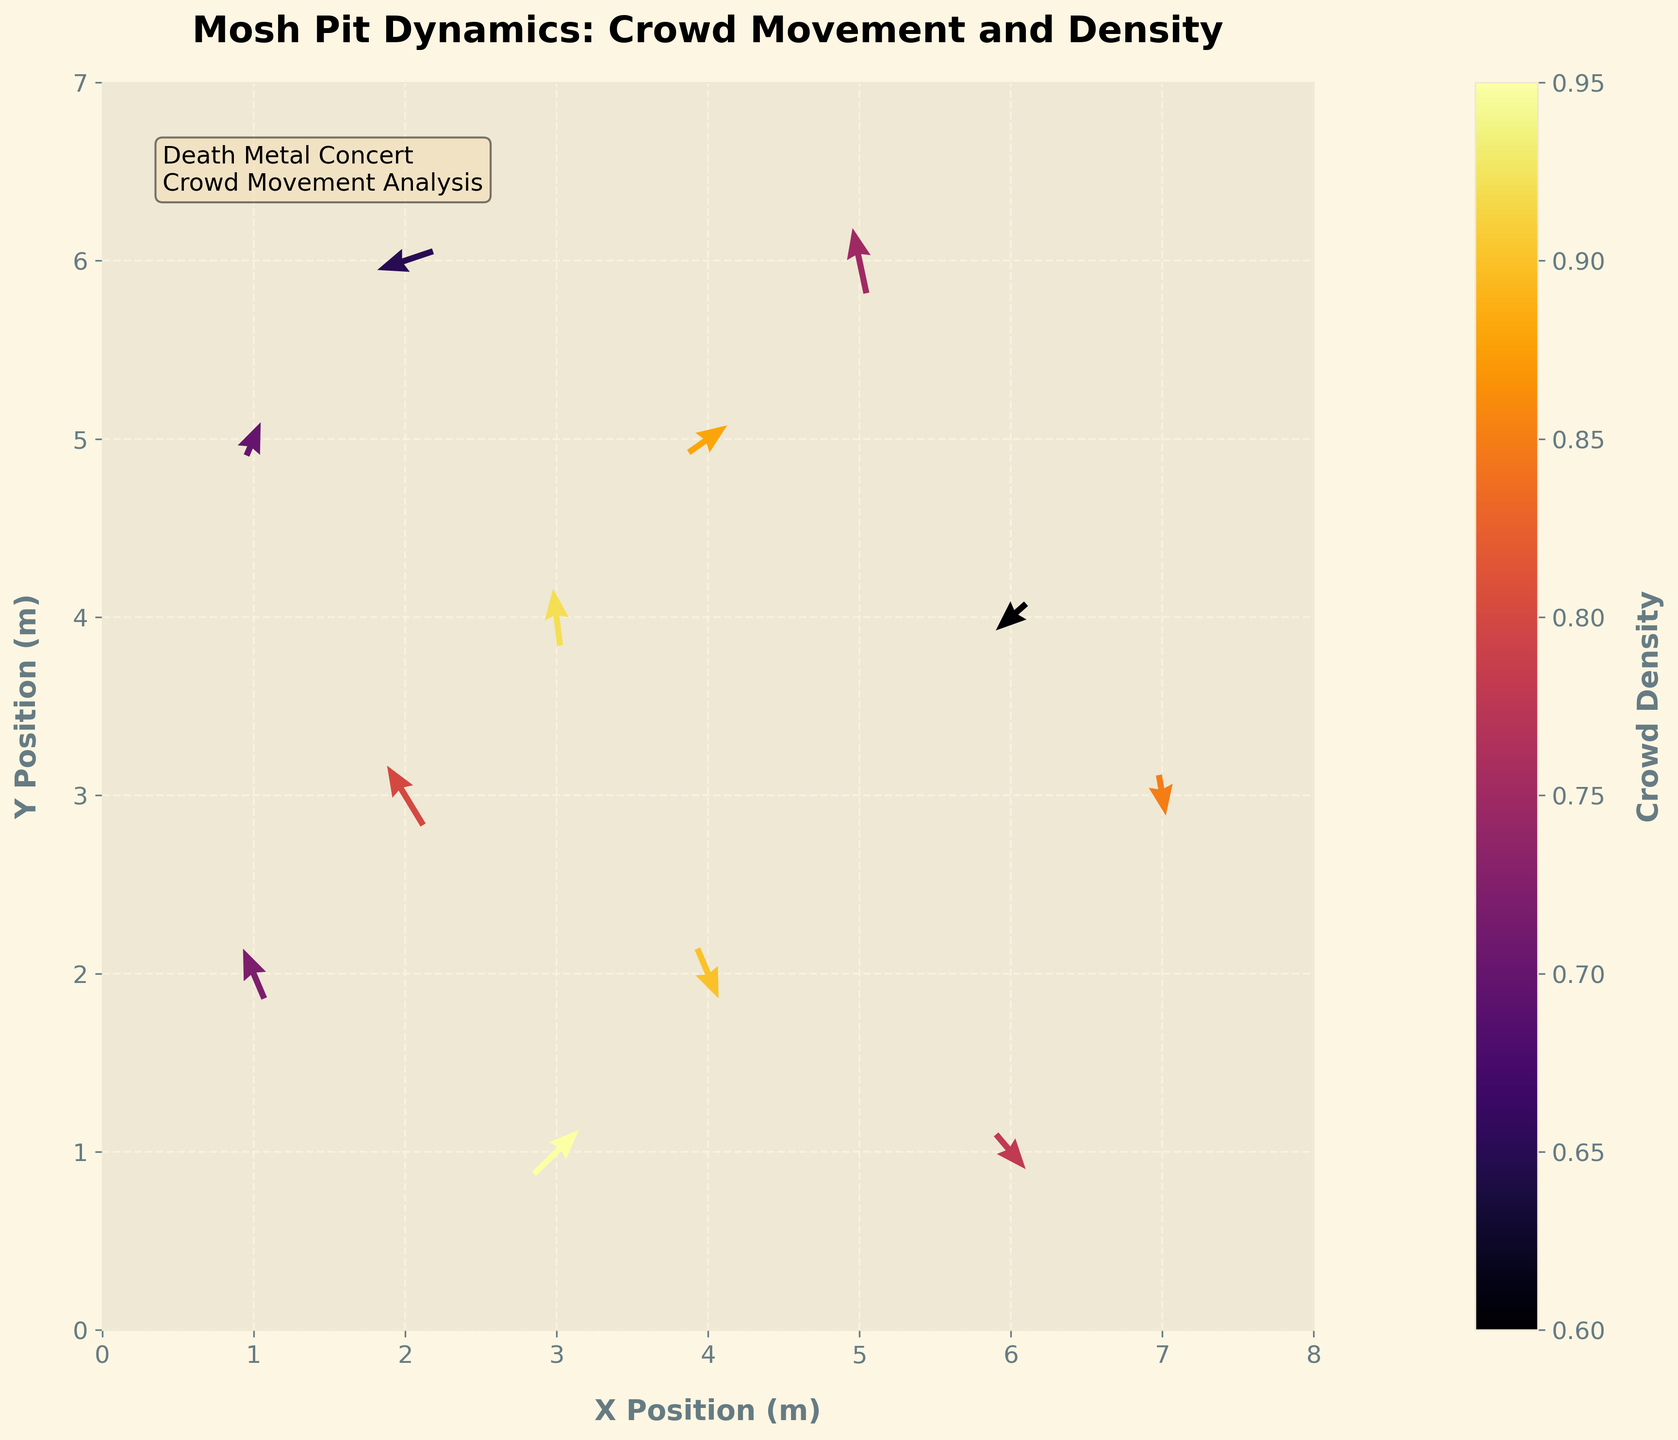Which area shows the highest crowd density? The highest crowd density is indicated by the darkest color on the color bar. In the plot, this can be observed at the location (3,1), where the density is 0.95.
Answer: (3,1) What is the title of the plot? The title of the plot is displayed at the top and reads "Mosh Pit Dynamics: Crowd Movement and Density".
Answer: Mosh Pit Dynamics: Crowd Movement and Density How many data points are shown in total? Each arrow represents a data point. By counting the arrows, we find there are 12 data points in total.
Answer: 12 Which direction is the crowd moving at position (1, 2)? From the quiver arrow pointing direction at (1, 2), the crowd is moving towards the top left. Specifically, u=-0.3 and v=0.6.
Answer: Top left What is the range of the x-axis? The x-axis range can be observed by looking at the axis limits. It ranges from 0 to 8 meters.
Answer: 0 to 8 meters Which point has both negative u and v components in its movement? By examining each arrow's direction, point (6, 4) shows both u and v as negative since the arrow is pointing towards the bottom left direction with u=-0.4 and v=-0.3.
Answer: (6, 4) Which positions have the highest and lowest crowd densities? Compare them. The position with the highest density is (3, 1) with a density of 0.95, and the position with the lowest density is (6, 4) with a density of 0.6. The difference between them is 0.35.
Answer: Highest: (3,1), Lowest: (6,4), Difference: 0.35 Is there any point where the crowd is moving straight vertically? Vertical movement means u=0. By checking the plot, no arrows have exactly zero horizontal movement (u component).
Answer: No What is the average crowd density of the points clustered in the upper part of the plot (y >= 5)? The points with y >= 5 are (1, 5), (2, 6), (4, 5), and (5, 6). The densities are 0.7, 0.65, 0.88, and 0.75 respectively. The average density is (0.7 + 0.65 + 0.88 + 0.75) / 4 = 0.745.
Answer: 0.745 